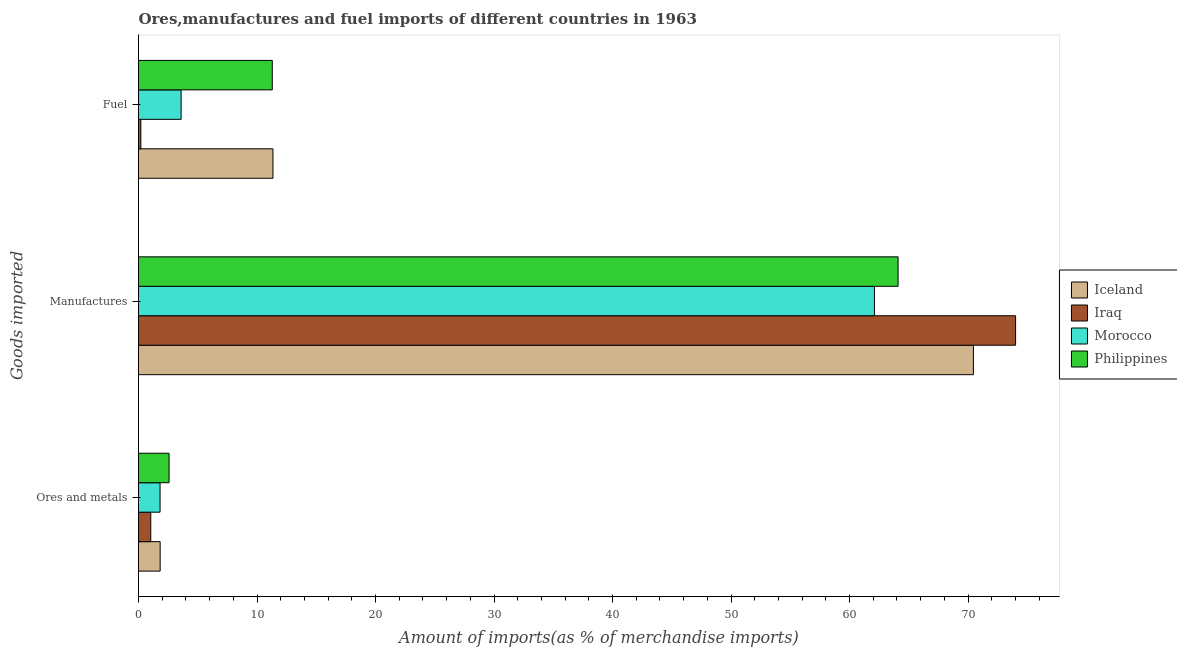How many different coloured bars are there?
Your answer should be very brief. 4. How many groups of bars are there?
Give a very brief answer. 3. Are the number of bars per tick equal to the number of legend labels?
Give a very brief answer. Yes. Are the number of bars on each tick of the Y-axis equal?
Offer a very short reply. Yes. How many bars are there on the 2nd tick from the top?
Make the answer very short. 4. How many bars are there on the 1st tick from the bottom?
Your response must be concise. 4. What is the label of the 1st group of bars from the top?
Keep it short and to the point. Fuel. What is the percentage of manufactures imports in Philippines?
Your response must be concise. 64.1. Across all countries, what is the maximum percentage of ores and metals imports?
Provide a short and direct response. 2.58. Across all countries, what is the minimum percentage of fuel imports?
Offer a very short reply. 0.2. In which country was the percentage of ores and metals imports maximum?
Offer a very short reply. Philippines. In which country was the percentage of fuel imports minimum?
Ensure brevity in your answer.  Iraq. What is the total percentage of fuel imports in the graph?
Give a very brief answer. 26.43. What is the difference between the percentage of fuel imports in Iceland and that in Philippines?
Your response must be concise. 0.06. What is the difference between the percentage of manufactures imports in Iraq and the percentage of ores and metals imports in Iceland?
Offer a terse response. 72.19. What is the average percentage of manufactures imports per country?
Your response must be concise. 67.67. What is the difference between the percentage of ores and metals imports and percentage of fuel imports in Philippines?
Make the answer very short. -8.71. In how many countries, is the percentage of ores and metals imports greater than 74 %?
Offer a terse response. 0. What is the ratio of the percentage of fuel imports in Iraq to that in Morocco?
Keep it short and to the point. 0.05. Is the percentage of manufactures imports in Iceland less than that in Iraq?
Provide a succinct answer. Yes. What is the difference between the highest and the second highest percentage of manufactures imports?
Keep it short and to the point. 3.56. What is the difference between the highest and the lowest percentage of ores and metals imports?
Offer a very short reply. 1.54. In how many countries, is the percentage of ores and metals imports greater than the average percentage of ores and metals imports taken over all countries?
Your answer should be compact. 3. Is the sum of the percentage of fuel imports in Iceland and Morocco greater than the maximum percentage of ores and metals imports across all countries?
Provide a succinct answer. Yes. What does the 2nd bar from the bottom in Ores and metals represents?
Make the answer very short. Iraq. Is it the case that in every country, the sum of the percentage of ores and metals imports and percentage of manufactures imports is greater than the percentage of fuel imports?
Your response must be concise. Yes. Are all the bars in the graph horizontal?
Make the answer very short. Yes. What is the difference between two consecutive major ticks on the X-axis?
Your response must be concise. 10. Are the values on the major ticks of X-axis written in scientific E-notation?
Ensure brevity in your answer.  No. Does the graph contain any zero values?
Provide a succinct answer. No. How many legend labels are there?
Offer a terse response. 4. How are the legend labels stacked?
Provide a succinct answer. Vertical. What is the title of the graph?
Make the answer very short. Ores,manufactures and fuel imports of different countries in 1963. What is the label or title of the X-axis?
Keep it short and to the point. Amount of imports(as % of merchandise imports). What is the label or title of the Y-axis?
Offer a very short reply. Goods imported. What is the Amount of imports(as % of merchandise imports) of Iceland in Ores and metals?
Provide a short and direct response. 1.83. What is the Amount of imports(as % of merchandise imports) in Iraq in Ores and metals?
Provide a succinct answer. 1.03. What is the Amount of imports(as % of merchandise imports) in Morocco in Ores and metals?
Offer a terse response. 1.82. What is the Amount of imports(as % of merchandise imports) of Philippines in Ores and metals?
Keep it short and to the point. 2.58. What is the Amount of imports(as % of merchandise imports) in Iceland in Manufactures?
Your response must be concise. 70.45. What is the Amount of imports(as % of merchandise imports) of Iraq in Manufactures?
Your answer should be compact. 74.01. What is the Amount of imports(as % of merchandise imports) in Morocco in Manufactures?
Your answer should be compact. 62.1. What is the Amount of imports(as % of merchandise imports) of Philippines in Manufactures?
Give a very brief answer. 64.1. What is the Amount of imports(as % of merchandise imports) in Iceland in Fuel?
Make the answer very short. 11.35. What is the Amount of imports(as % of merchandise imports) of Iraq in Fuel?
Provide a short and direct response. 0.2. What is the Amount of imports(as % of merchandise imports) of Morocco in Fuel?
Ensure brevity in your answer.  3.59. What is the Amount of imports(as % of merchandise imports) in Philippines in Fuel?
Offer a terse response. 11.29. Across all Goods imported, what is the maximum Amount of imports(as % of merchandise imports) in Iceland?
Make the answer very short. 70.45. Across all Goods imported, what is the maximum Amount of imports(as % of merchandise imports) of Iraq?
Ensure brevity in your answer.  74.01. Across all Goods imported, what is the maximum Amount of imports(as % of merchandise imports) in Morocco?
Your response must be concise. 62.1. Across all Goods imported, what is the maximum Amount of imports(as % of merchandise imports) in Philippines?
Give a very brief answer. 64.1. Across all Goods imported, what is the minimum Amount of imports(as % of merchandise imports) of Iceland?
Make the answer very short. 1.83. Across all Goods imported, what is the minimum Amount of imports(as % of merchandise imports) of Iraq?
Make the answer very short. 0.2. Across all Goods imported, what is the minimum Amount of imports(as % of merchandise imports) of Morocco?
Your answer should be very brief. 1.82. Across all Goods imported, what is the minimum Amount of imports(as % of merchandise imports) of Philippines?
Your answer should be compact. 2.58. What is the total Amount of imports(as % of merchandise imports) in Iceland in the graph?
Make the answer very short. 83.63. What is the total Amount of imports(as % of merchandise imports) in Iraq in the graph?
Make the answer very short. 75.25. What is the total Amount of imports(as % of merchandise imports) of Morocco in the graph?
Your response must be concise. 67.51. What is the total Amount of imports(as % of merchandise imports) of Philippines in the graph?
Ensure brevity in your answer.  77.96. What is the difference between the Amount of imports(as % of merchandise imports) in Iceland in Ores and metals and that in Manufactures?
Offer a terse response. -68.63. What is the difference between the Amount of imports(as % of merchandise imports) in Iraq in Ores and metals and that in Manufactures?
Your answer should be compact. -72.98. What is the difference between the Amount of imports(as % of merchandise imports) in Morocco in Ores and metals and that in Manufactures?
Provide a succinct answer. -60.28. What is the difference between the Amount of imports(as % of merchandise imports) in Philippines in Ores and metals and that in Manufactures?
Your response must be concise. -61.52. What is the difference between the Amount of imports(as % of merchandise imports) of Iceland in Ores and metals and that in Fuel?
Provide a succinct answer. -9.52. What is the difference between the Amount of imports(as % of merchandise imports) in Iraq in Ores and metals and that in Fuel?
Your response must be concise. 0.84. What is the difference between the Amount of imports(as % of merchandise imports) of Morocco in Ores and metals and that in Fuel?
Ensure brevity in your answer.  -1.77. What is the difference between the Amount of imports(as % of merchandise imports) of Philippines in Ores and metals and that in Fuel?
Give a very brief answer. -8.71. What is the difference between the Amount of imports(as % of merchandise imports) of Iceland in Manufactures and that in Fuel?
Offer a very short reply. 59.11. What is the difference between the Amount of imports(as % of merchandise imports) of Iraq in Manufactures and that in Fuel?
Your answer should be compact. 73.82. What is the difference between the Amount of imports(as % of merchandise imports) in Morocco in Manufactures and that in Fuel?
Offer a terse response. 58.51. What is the difference between the Amount of imports(as % of merchandise imports) of Philippines in Manufactures and that in Fuel?
Provide a short and direct response. 52.81. What is the difference between the Amount of imports(as % of merchandise imports) in Iceland in Ores and metals and the Amount of imports(as % of merchandise imports) in Iraq in Manufactures?
Make the answer very short. -72.19. What is the difference between the Amount of imports(as % of merchandise imports) of Iceland in Ores and metals and the Amount of imports(as % of merchandise imports) of Morocco in Manufactures?
Your answer should be compact. -60.27. What is the difference between the Amount of imports(as % of merchandise imports) in Iceland in Ores and metals and the Amount of imports(as % of merchandise imports) in Philippines in Manufactures?
Ensure brevity in your answer.  -62.27. What is the difference between the Amount of imports(as % of merchandise imports) of Iraq in Ores and metals and the Amount of imports(as % of merchandise imports) of Morocco in Manufactures?
Offer a terse response. -61.07. What is the difference between the Amount of imports(as % of merchandise imports) in Iraq in Ores and metals and the Amount of imports(as % of merchandise imports) in Philippines in Manufactures?
Ensure brevity in your answer.  -63.06. What is the difference between the Amount of imports(as % of merchandise imports) in Morocco in Ores and metals and the Amount of imports(as % of merchandise imports) in Philippines in Manufactures?
Provide a short and direct response. -62.28. What is the difference between the Amount of imports(as % of merchandise imports) of Iceland in Ores and metals and the Amount of imports(as % of merchandise imports) of Iraq in Fuel?
Keep it short and to the point. 1.63. What is the difference between the Amount of imports(as % of merchandise imports) of Iceland in Ores and metals and the Amount of imports(as % of merchandise imports) of Morocco in Fuel?
Your answer should be compact. -1.77. What is the difference between the Amount of imports(as % of merchandise imports) of Iceland in Ores and metals and the Amount of imports(as % of merchandise imports) of Philippines in Fuel?
Keep it short and to the point. -9.46. What is the difference between the Amount of imports(as % of merchandise imports) in Iraq in Ores and metals and the Amount of imports(as % of merchandise imports) in Morocco in Fuel?
Provide a short and direct response. -2.56. What is the difference between the Amount of imports(as % of merchandise imports) of Iraq in Ores and metals and the Amount of imports(as % of merchandise imports) of Philippines in Fuel?
Give a very brief answer. -10.25. What is the difference between the Amount of imports(as % of merchandise imports) in Morocco in Ores and metals and the Amount of imports(as % of merchandise imports) in Philippines in Fuel?
Your response must be concise. -9.47. What is the difference between the Amount of imports(as % of merchandise imports) of Iceland in Manufactures and the Amount of imports(as % of merchandise imports) of Iraq in Fuel?
Your answer should be compact. 70.26. What is the difference between the Amount of imports(as % of merchandise imports) in Iceland in Manufactures and the Amount of imports(as % of merchandise imports) in Morocco in Fuel?
Make the answer very short. 66.86. What is the difference between the Amount of imports(as % of merchandise imports) of Iceland in Manufactures and the Amount of imports(as % of merchandise imports) of Philippines in Fuel?
Keep it short and to the point. 59.16. What is the difference between the Amount of imports(as % of merchandise imports) of Iraq in Manufactures and the Amount of imports(as % of merchandise imports) of Morocco in Fuel?
Ensure brevity in your answer.  70.42. What is the difference between the Amount of imports(as % of merchandise imports) in Iraq in Manufactures and the Amount of imports(as % of merchandise imports) in Philippines in Fuel?
Ensure brevity in your answer.  62.72. What is the difference between the Amount of imports(as % of merchandise imports) of Morocco in Manufactures and the Amount of imports(as % of merchandise imports) of Philippines in Fuel?
Provide a succinct answer. 50.81. What is the average Amount of imports(as % of merchandise imports) of Iceland per Goods imported?
Give a very brief answer. 27.88. What is the average Amount of imports(as % of merchandise imports) of Iraq per Goods imported?
Ensure brevity in your answer.  25.08. What is the average Amount of imports(as % of merchandise imports) of Morocco per Goods imported?
Provide a succinct answer. 22.5. What is the average Amount of imports(as % of merchandise imports) in Philippines per Goods imported?
Give a very brief answer. 25.99. What is the difference between the Amount of imports(as % of merchandise imports) of Iceland and Amount of imports(as % of merchandise imports) of Iraq in Ores and metals?
Your answer should be compact. 0.79. What is the difference between the Amount of imports(as % of merchandise imports) of Iceland and Amount of imports(as % of merchandise imports) of Morocco in Ores and metals?
Ensure brevity in your answer.  0.01. What is the difference between the Amount of imports(as % of merchandise imports) of Iceland and Amount of imports(as % of merchandise imports) of Philippines in Ores and metals?
Your answer should be compact. -0.75. What is the difference between the Amount of imports(as % of merchandise imports) of Iraq and Amount of imports(as % of merchandise imports) of Morocco in Ores and metals?
Give a very brief answer. -0.79. What is the difference between the Amount of imports(as % of merchandise imports) in Iraq and Amount of imports(as % of merchandise imports) in Philippines in Ores and metals?
Provide a succinct answer. -1.54. What is the difference between the Amount of imports(as % of merchandise imports) in Morocco and Amount of imports(as % of merchandise imports) in Philippines in Ores and metals?
Offer a terse response. -0.76. What is the difference between the Amount of imports(as % of merchandise imports) of Iceland and Amount of imports(as % of merchandise imports) of Iraq in Manufactures?
Ensure brevity in your answer.  -3.56. What is the difference between the Amount of imports(as % of merchandise imports) in Iceland and Amount of imports(as % of merchandise imports) in Morocco in Manufactures?
Provide a succinct answer. 8.35. What is the difference between the Amount of imports(as % of merchandise imports) of Iceland and Amount of imports(as % of merchandise imports) of Philippines in Manufactures?
Offer a terse response. 6.36. What is the difference between the Amount of imports(as % of merchandise imports) of Iraq and Amount of imports(as % of merchandise imports) of Morocco in Manufactures?
Your answer should be compact. 11.91. What is the difference between the Amount of imports(as % of merchandise imports) in Iraq and Amount of imports(as % of merchandise imports) in Philippines in Manufactures?
Ensure brevity in your answer.  9.92. What is the difference between the Amount of imports(as % of merchandise imports) of Morocco and Amount of imports(as % of merchandise imports) of Philippines in Manufactures?
Provide a short and direct response. -2. What is the difference between the Amount of imports(as % of merchandise imports) in Iceland and Amount of imports(as % of merchandise imports) in Iraq in Fuel?
Provide a succinct answer. 11.15. What is the difference between the Amount of imports(as % of merchandise imports) of Iceland and Amount of imports(as % of merchandise imports) of Morocco in Fuel?
Keep it short and to the point. 7.75. What is the difference between the Amount of imports(as % of merchandise imports) in Iceland and Amount of imports(as % of merchandise imports) in Philippines in Fuel?
Your answer should be very brief. 0.06. What is the difference between the Amount of imports(as % of merchandise imports) in Iraq and Amount of imports(as % of merchandise imports) in Morocco in Fuel?
Make the answer very short. -3.4. What is the difference between the Amount of imports(as % of merchandise imports) of Iraq and Amount of imports(as % of merchandise imports) of Philippines in Fuel?
Offer a terse response. -11.09. What is the difference between the Amount of imports(as % of merchandise imports) in Morocco and Amount of imports(as % of merchandise imports) in Philippines in Fuel?
Give a very brief answer. -7.69. What is the ratio of the Amount of imports(as % of merchandise imports) in Iceland in Ores and metals to that in Manufactures?
Your response must be concise. 0.03. What is the ratio of the Amount of imports(as % of merchandise imports) of Iraq in Ores and metals to that in Manufactures?
Make the answer very short. 0.01. What is the ratio of the Amount of imports(as % of merchandise imports) of Morocco in Ores and metals to that in Manufactures?
Provide a short and direct response. 0.03. What is the ratio of the Amount of imports(as % of merchandise imports) in Philippines in Ores and metals to that in Manufactures?
Your answer should be very brief. 0.04. What is the ratio of the Amount of imports(as % of merchandise imports) of Iceland in Ores and metals to that in Fuel?
Your response must be concise. 0.16. What is the ratio of the Amount of imports(as % of merchandise imports) of Iraq in Ores and metals to that in Fuel?
Your answer should be compact. 5.23. What is the ratio of the Amount of imports(as % of merchandise imports) of Morocco in Ores and metals to that in Fuel?
Your response must be concise. 0.51. What is the ratio of the Amount of imports(as % of merchandise imports) in Philippines in Ores and metals to that in Fuel?
Provide a short and direct response. 0.23. What is the ratio of the Amount of imports(as % of merchandise imports) of Iceland in Manufactures to that in Fuel?
Provide a succinct answer. 6.21. What is the ratio of the Amount of imports(as % of merchandise imports) in Iraq in Manufactures to that in Fuel?
Provide a succinct answer. 374.54. What is the ratio of the Amount of imports(as % of merchandise imports) in Morocco in Manufactures to that in Fuel?
Give a very brief answer. 17.28. What is the ratio of the Amount of imports(as % of merchandise imports) of Philippines in Manufactures to that in Fuel?
Provide a succinct answer. 5.68. What is the difference between the highest and the second highest Amount of imports(as % of merchandise imports) in Iceland?
Give a very brief answer. 59.11. What is the difference between the highest and the second highest Amount of imports(as % of merchandise imports) in Iraq?
Offer a terse response. 72.98. What is the difference between the highest and the second highest Amount of imports(as % of merchandise imports) in Morocco?
Provide a short and direct response. 58.51. What is the difference between the highest and the second highest Amount of imports(as % of merchandise imports) of Philippines?
Your answer should be compact. 52.81. What is the difference between the highest and the lowest Amount of imports(as % of merchandise imports) of Iceland?
Keep it short and to the point. 68.63. What is the difference between the highest and the lowest Amount of imports(as % of merchandise imports) of Iraq?
Offer a very short reply. 73.82. What is the difference between the highest and the lowest Amount of imports(as % of merchandise imports) of Morocco?
Keep it short and to the point. 60.28. What is the difference between the highest and the lowest Amount of imports(as % of merchandise imports) in Philippines?
Your response must be concise. 61.52. 